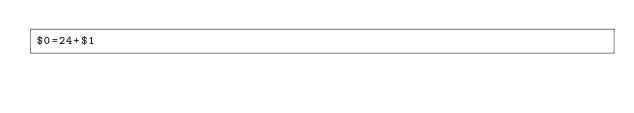<code> <loc_0><loc_0><loc_500><loc_500><_Awk_>$0=24+$1</code> 